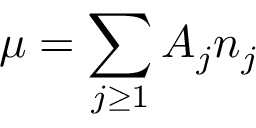<formula> <loc_0><loc_0><loc_500><loc_500>\mu = \sum _ { j \geq 1 } A _ { j } n _ { j }</formula> 